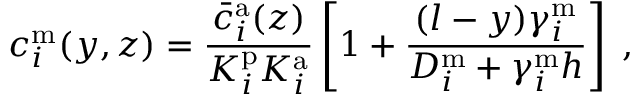<formula> <loc_0><loc_0><loc_500><loc_500>c _ { i } ^ { m } ( y , z ) = \frac { \bar { c } _ { i } ^ { a } ( z ) } { K _ { i } ^ { p } K _ { i } ^ { a } } \left [ 1 + \frac { ( l - y ) \gamma _ { i } ^ { m } } { D _ { i } ^ { m } + \gamma _ { i } ^ { m } h } \right ] \, ,</formula> 